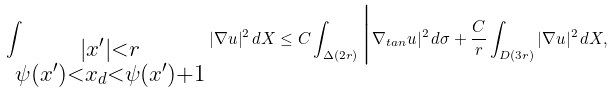Convert formula to latex. <formula><loc_0><loc_0><loc_500><loc_500>\int _ { \substack { | x ^ { \prime } | < r \\ \psi ( x ^ { \prime } ) < x _ { d } < \psi ( x ^ { \prime } ) + 1 } } | \nabla u | ^ { 2 } \, d X \leq C \int _ { \Delta ( 2 r ) } \Big | \nabla _ { t a n } u | ^ { 2 } \, d \sigma + \frac { C } { r } \int _ { D ( 3 r ) } | \nabla u | ^ { 2 } \, d X ,</formula> 